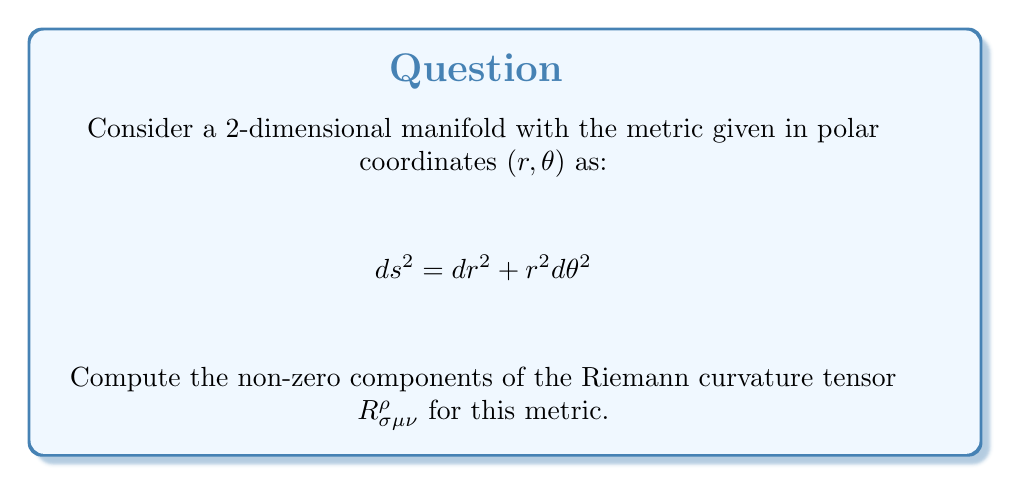Solve this math problem. To compute the Riemann curvature tensor, we'll follow these steps:

1) First, we need to calculate the Christoffel symbols $\Gamma^i_{jk}$. The formula is:

   $$\Gamma^i_{jk} = \frac{1}{2}g^{im}(\partial_j g_{km} + \partial_k g_{jm} - \partial_m g_{jk})$$

2) For our metric, $g_{11} = 1$, $g_{22} = r^2$, and $g_{12} = g_{21} = 0$. The inverse metric is $g^{11} = 1$, $g^{22} = \frac{1}{r^2}$, and $g^{12} = g^{21} = 0$.

3) Calculating the non-zero Christoffel symbols:
   
   $$\Gamma^1_{22} = -r$$
   $$\Gamma^2_{12} = \Gamma^2_{21} = \frac{1}{r}$$

4) Now, we can use the Riemann tensor formula:

   $$R^\rho_{\sigma\mu\nu} = \partial_\mu \Gamma^\rho_{\sigma\nu} - \partial_\nu \Gamma^\rho_{\sigma\mu} + \Gamma^\rho_{\lambda\mu}\Gamma^\lambda_{\sigma\nu} - \Gamma^\rho_{\lambda\nu}\Gamma^\lambda_{\sigma\mu}$$

5) Calculating the non-zero components:

   $$R^1_{212} = \partial_1 \Gamma^1_{22} - \partial_2 \Gamma^1_{21} + \Gamma^1_{11}\Gamma^1_{22} + \Gamma^1_{21}\Gamma^2_{22} - \Gamma^1_{12}\Gamma^1_{21} - \Gamma^1_{22}\Gamma^2_{21}$$
   $$= -1 - 0 + 0 + 0 - 0 - (-r)(\frac{1}{r}) = 0$$

   $$R^2_{121} = \partial_2 \Gamma^2_{11} - \partial_1 \Gamma^2_{21} + \Gamma^2_{12}\Gamma^1_{11} + \Gamma^2_{22}\Gamma^2_{21} - \Gamma^2_{11}\Gamma^1_{21} - \Gamma^2_{21}\Gamma^2_{11}$$
   $$= 0 - (-\frac{1}{r^2}) + 0 + 0 - 0 - 0 = \frac{1}{r^2}$$

6) All other components are either zero or can be derived from these by symmetry or antisymmetry properties of the Riemann tensor.
Answer: $R^2_{121} = -R^2_{112} = R^1_{212} = -R^1_{221} = \frac{1}{r^2}$, all other components are zero. 